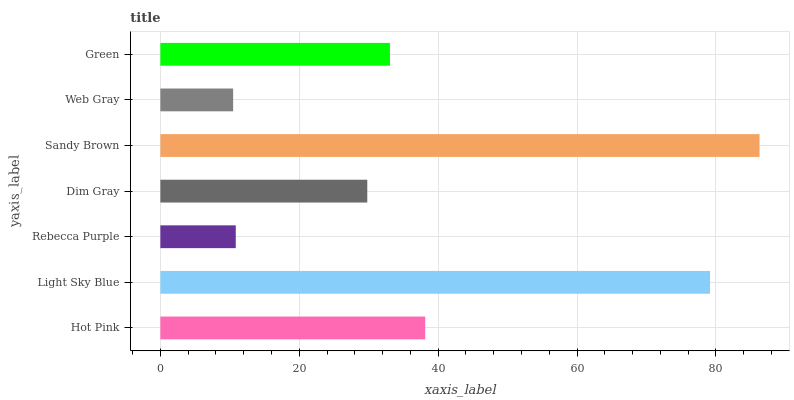Is Web Gray the minimum?
Answer yes or no. Yes. Is Sandy Brown the maximum?
Answer yes or no. Yes. Is Light Sky Blue the minimum?
Answer yes or no. No. Is Light Sky Blue the maximum?
Answer yes or no. No. Is Light Sky Blue greater than Hot Pink?
Answer yes or no. Yes. Is Hot Pink less than Light Sky Blue?
Answer yes or no. Yes. Is Hot Pink greater than Light Sky Blue?
Answer yes or no. No. Is Light Sky Blue less than Hot Pink?
Answer yes or no. No. Is Green the high median?
Answer yes or no. Yes. Is Green the low median?
Answer yes or no. Yes. Is Sandy Brown the high median?
Answer yes or no. No. Is Hot Pink the low median?
Answer yes or no. No. 